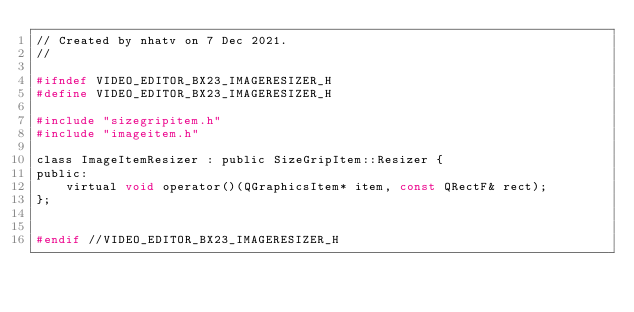<code> <loc_0><loc_0><loc_500><loc_500><_C_>// Created by nhatv on 7 Dec 2021.
//

#ifndef VIDEO_EDITOR_BX23_IMAGERESIZER_H
#define VIDEO_EDITOR_BX23_IMAGERESIZER_H

#include "sizegripitem.h"
#include "imageitem.h"

class ImageItemResizer : public SizeGripItem::Resizer {
public:
    virtual void operator()(QGraphicsItem* item, const QRectF& rect);
};


#endif //VIDEO_EDITOR_BX23_IMAGERESIZER_H
</code> 